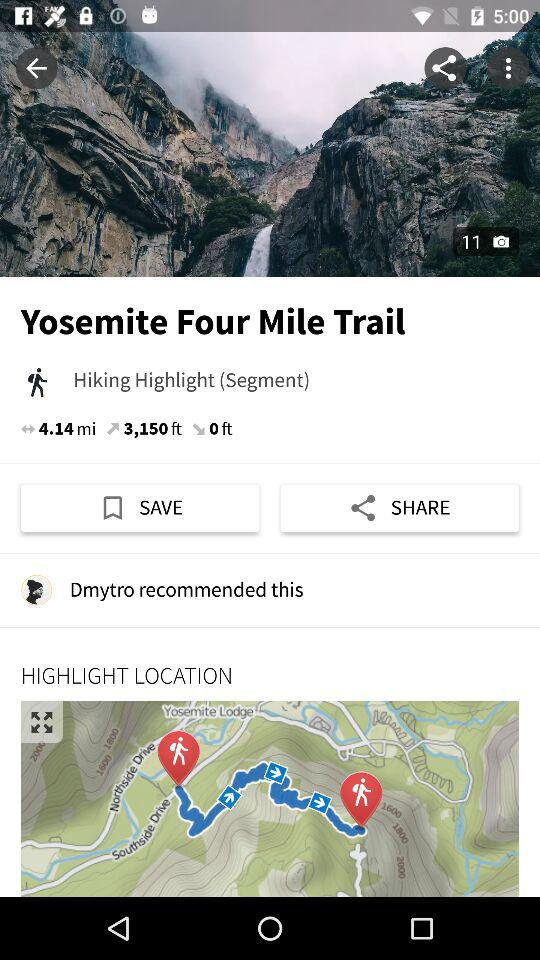How much is the Feet? How much elevation gain is there in feet? The elevation gain is 3,150 feet. 